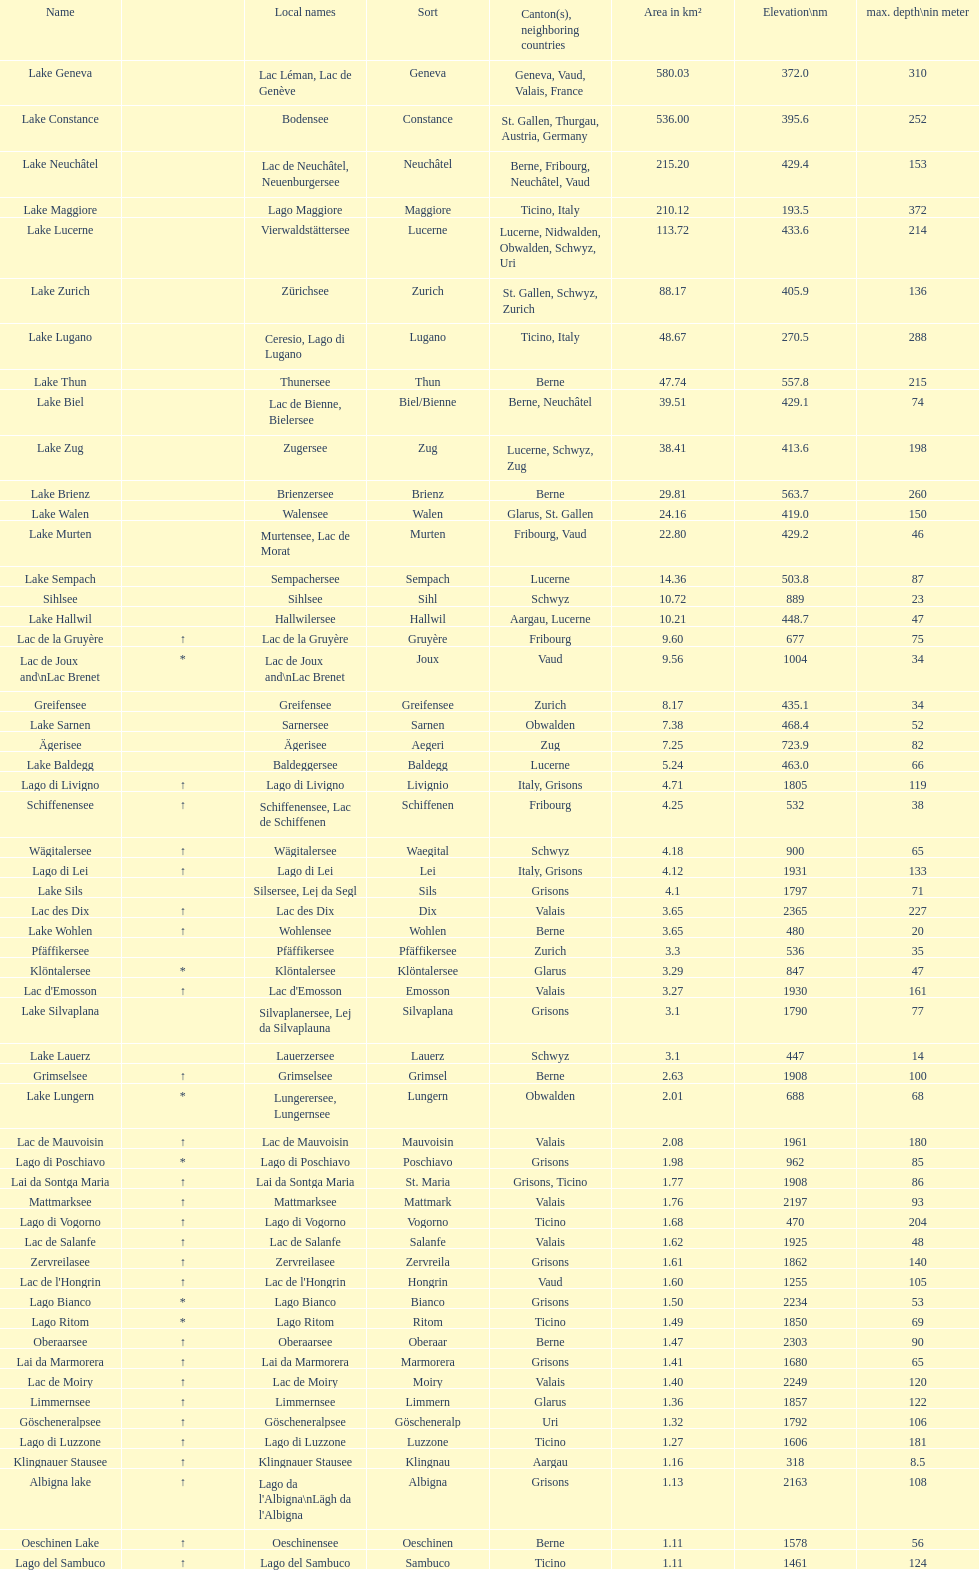Which is the only lake with a max depth of 372m? Lake Maggiore. 